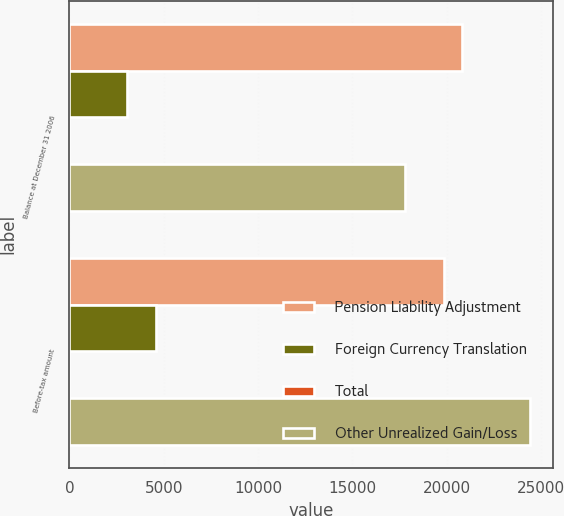Convert chart to OTSL. <chart><loc_0><loc_0><loc_500><loc_500><stacked_bar_chart><ecel><fcel>Balance at December 31 2006<fcel>Before-tax amount<nl><fcel>Pension Liability Adjustment<fcel>20819<fcel>19858<nl><fcel>Foreign Currency Translation<fcel>3038<fcel>4571<nl><fcel>Total<fcel>3<fcel>3<nl><fcel>Other Unrealized Gain/Loss<fcel>17784<fcel>24432<nl></chart> 